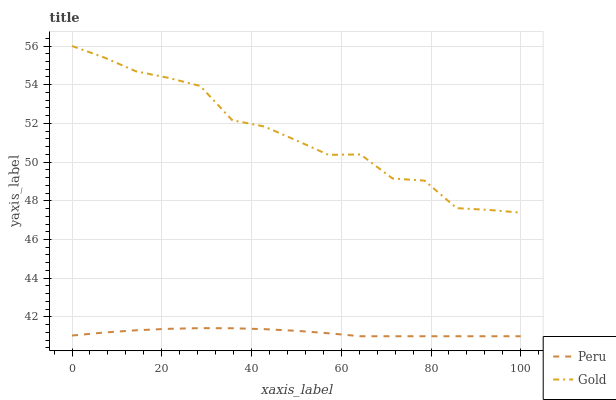Does Peru have the minimum area under the curve?
Answer yes or no. Yes. Does Gold have the maximum area under the curve?
Answer yes or no. Yes. Does Peru have the maximum area under the curve?
Answer yes or no. No. Is Peru the smoothest?
Answer yes or no. Yes. Is Gold the roughest?
Answer yes or no. Yes. Is Peru the roughest?
Answer yes or no. No. Does Peru have the lowest value?
Answer yes or no. Yes. Does Gold have the highest value?
Answer yes or no. Yes. Does Peru have the highest value?
Answer yes or no. No. Is Peru less than Gold?
Answer yes or no. Yes. Is Gold greater than Peru?
Answer yes or no. Yes. Does Peru intersect Gold?
Answer yes or no. No. 